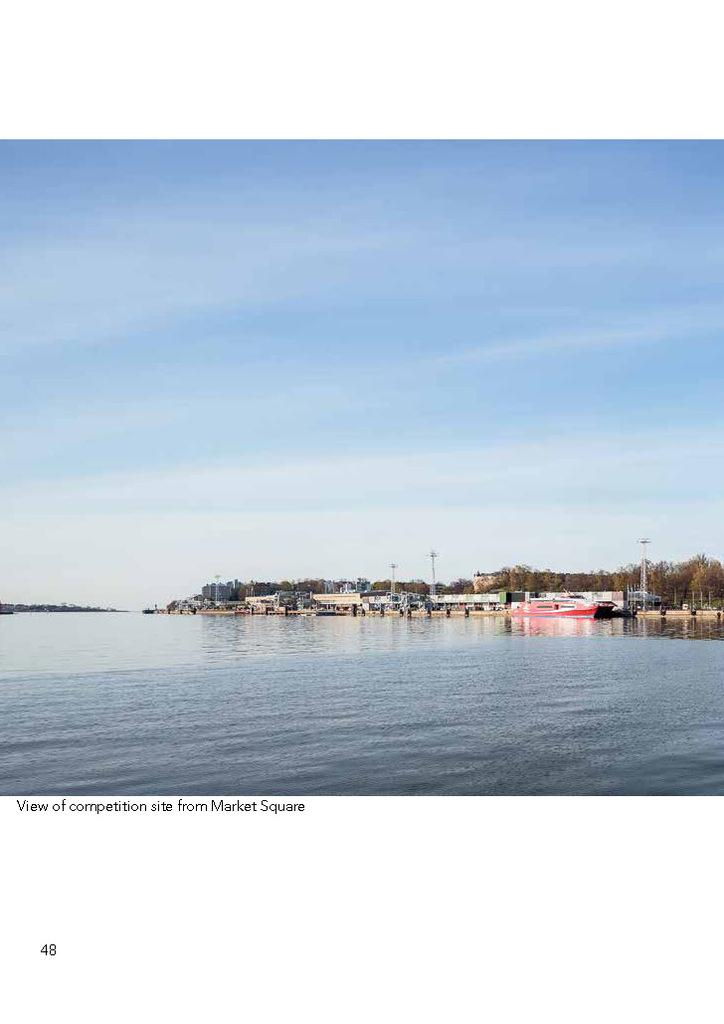What is the primary element in the image? There is water in the image. What can be seen floating on the water? There are boats in the image. What are the poles used for in the image? The poles are likely used for mooring or anchoring the boats. What type of vegetation is present in the image? There are trees in the image. Can you describe any other objects in the image? There are some objects in the image, but their purpose is not clear. What is visible in the background of the image? The sky is visible in the background of the image. Is there any text present in the image? Yes, there is text in the bottom left corner of the image. How many worms can be seen crawling on the boats in the image? There are no worms present in the image; it features water, boats, poles, trees, and text. 